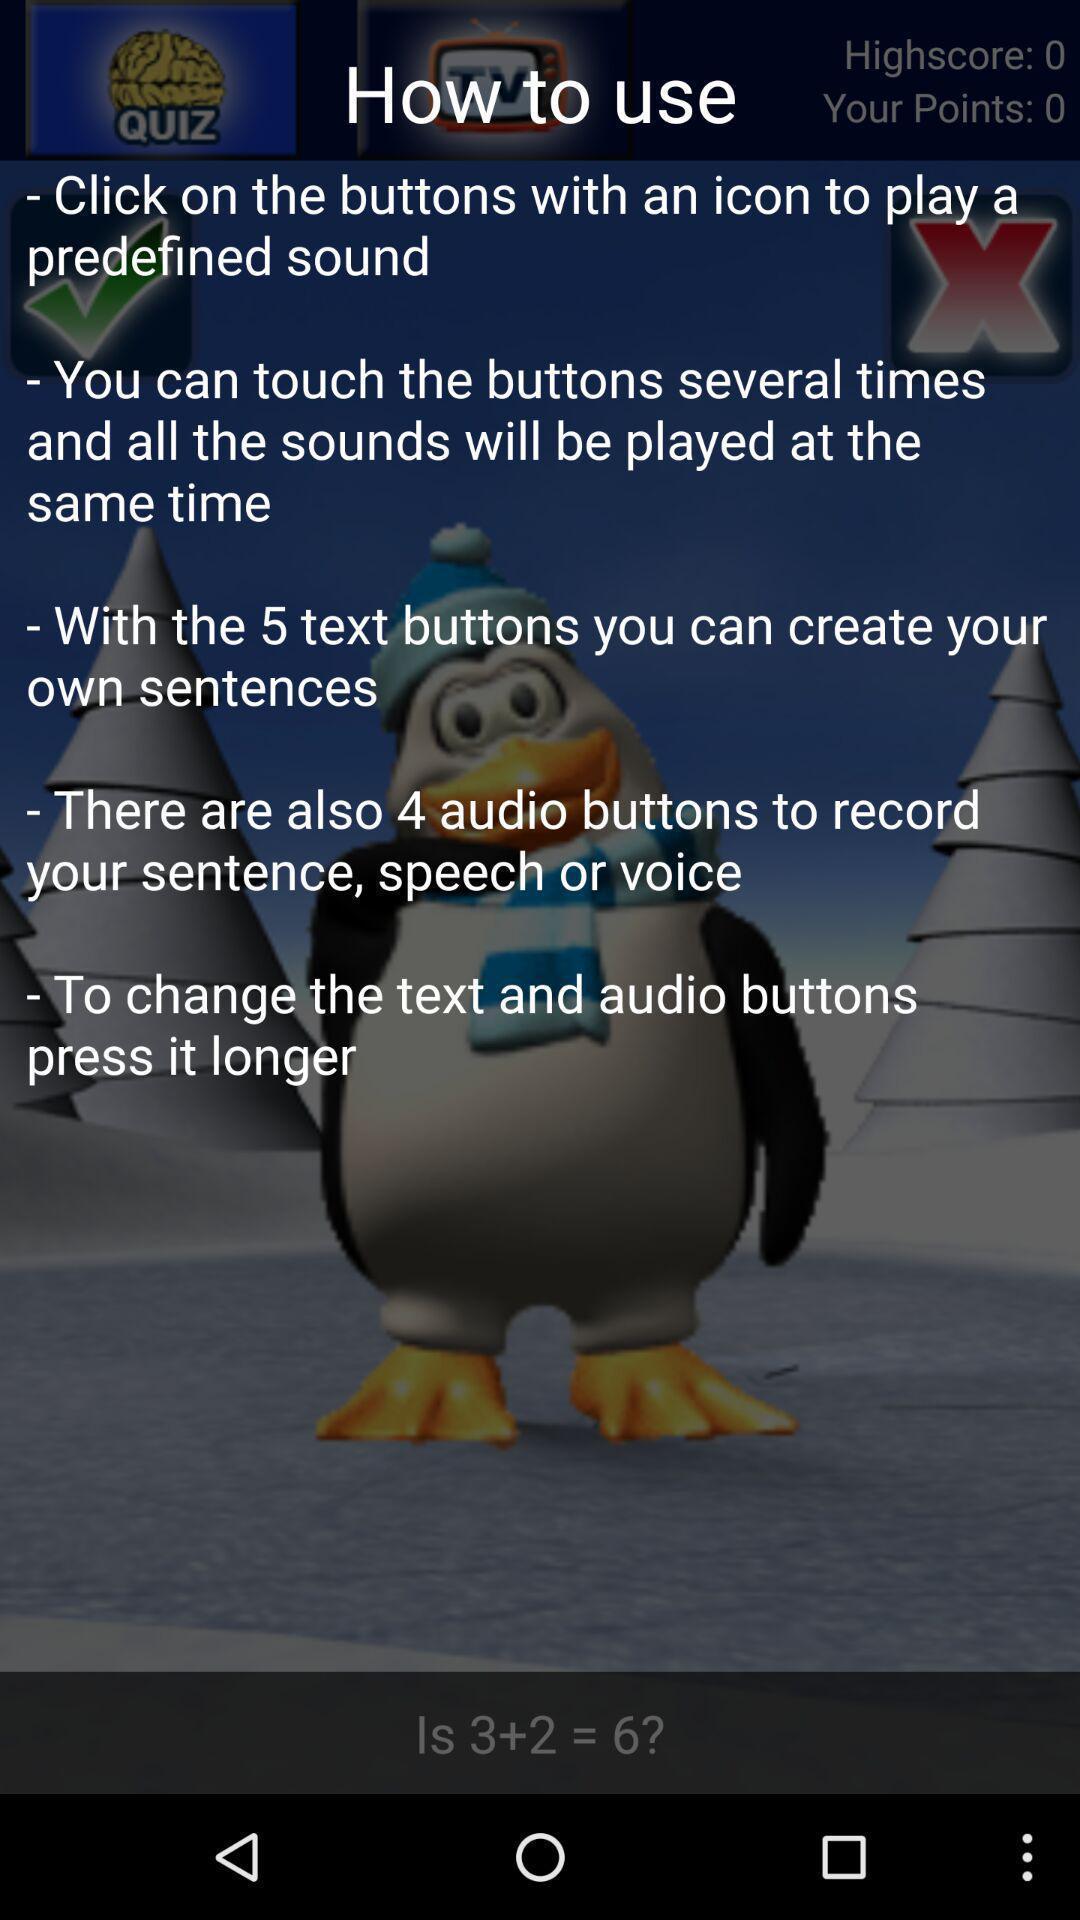Explain the elements present in this screenshot. Screen showing instructions on how to use the app. 